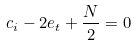Convert formula to latex. <formula><loc_0><loc_0><loc_500><loc_500>c _ { i } - 2 e _ { t } + \frac { N } { 2 } & = 0</formula> 